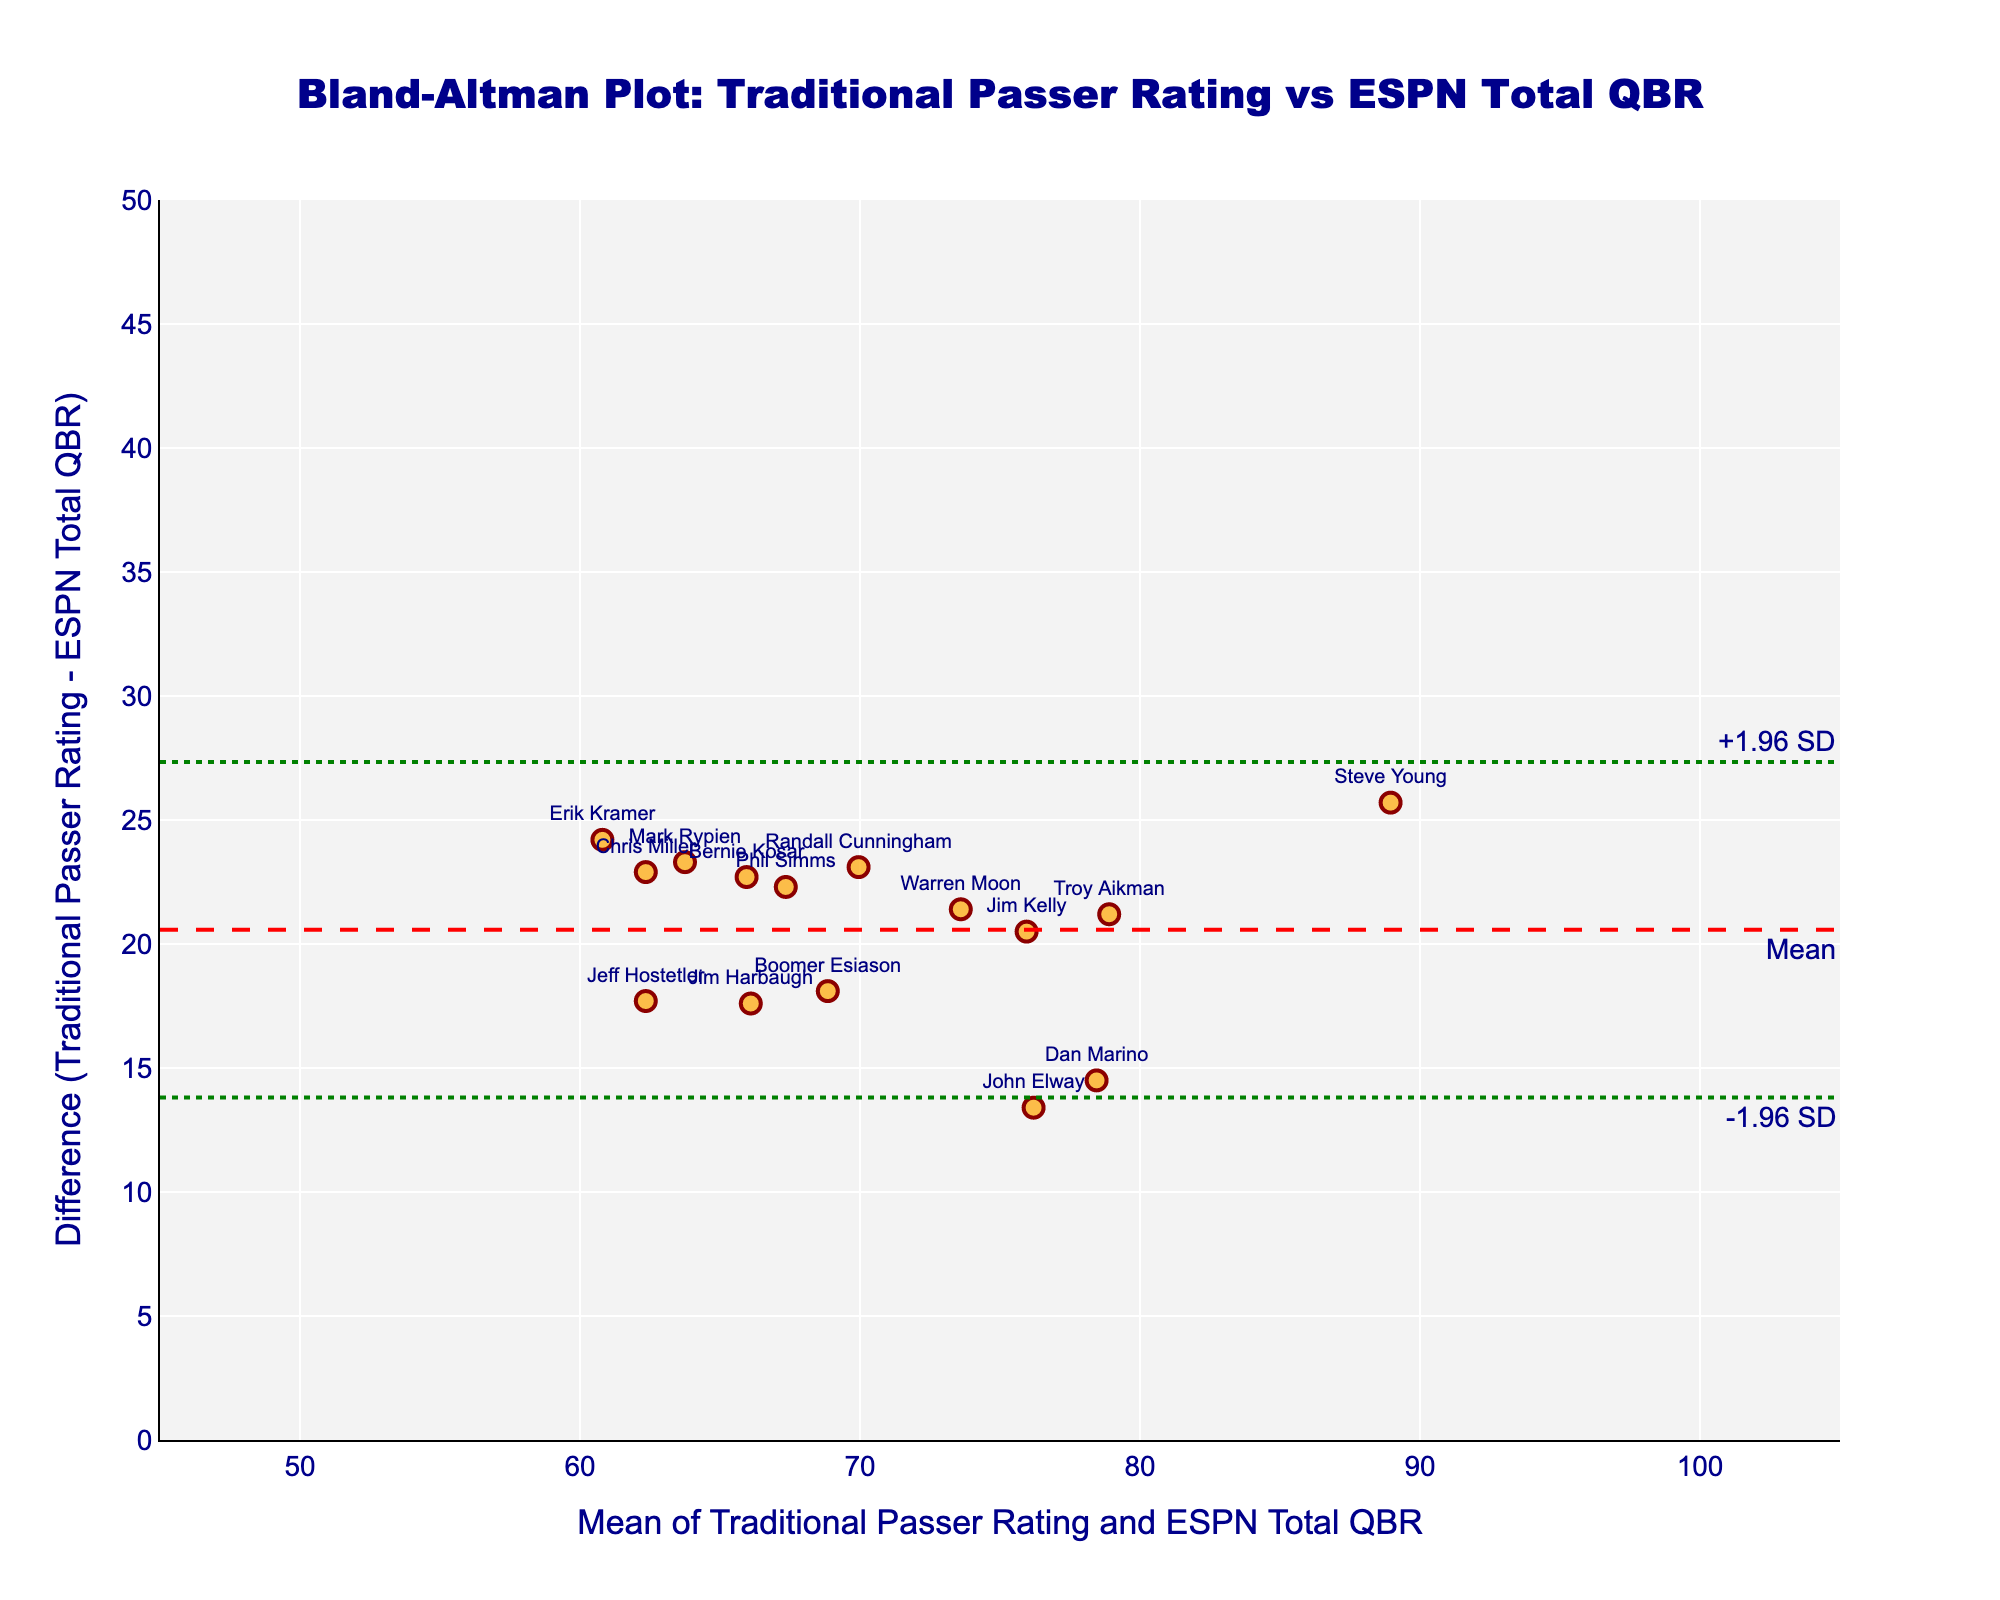what is the title of the plot? The title is usually displayed at the top of the plot. In this case, the title reads "Bland-Altman Plot: Traditional Passer Rating vs ESPN Total QBR".
Answer: Bland-Altman Plot: Traditional Passer Rating vs ESPN Total QBR How many quarterbacks are represented in the plot? Each data point in the plot represents a quarterback. By counting the number of data points, which correspond to the number of labels, we observe there are 15 quarterbacks.
Answer: 15 What is the range of the x-axis? The range of the x-axis is explicitly stated in the axis properties. The x-axis spans from 45 to 105 mean ratings.
Answer: 45 to 105 Which quarterback has the highest mean rating? To find the quarterback with the highest mean rating, we look at the data point with the highest x-value. Steve Young has the highest mean rating.
Answer: Steve Young What does the red dashed line represent? In a Bland-Altman plot, the red dashed line typically represents the mean difference between the two methods. It's a horizontal line at the mean difference value.
Answer: Mean difference What do the dotted green lines signify? The dotted green lines in a Bland-Altman plot are usually positioned at ±1.96 times the standard deviation from the mean difference. These indicate the limits of agreement.
Answer: ±1.96 standard deviations Which quarterback exhibits the largest difference between the two ratings? To find the largest difference, identify the data point with the maximum vertical distance from the mean difference line. Randall Cunningham shows the largest difference between the two ratings.
Answer: Randall Cunningham What is the value of the mean difference line? The mean difference line is marked with "Mean" and is the average difference between the Traditional Passer Rating and ESPN Total QBR. The exact value can be found from visual inspection of its y-coordinate, calculated previously.
Answer: Approximately 19.0 Are there any quarterbacks whose difference falls outside ±1.96 SD? To answer this, look for any data points lying outside the two green lines. All the data points lie within these lines, so no quarterback falls outside ±1.96 SD.
Answer: No Which quarterback has the closest mean rating to 80? To find the closest mean rating to 80, locate the data point nearest to x = 80. Jim Kelly has the closest mean rating to 80.
Answer: Jim Kelly 